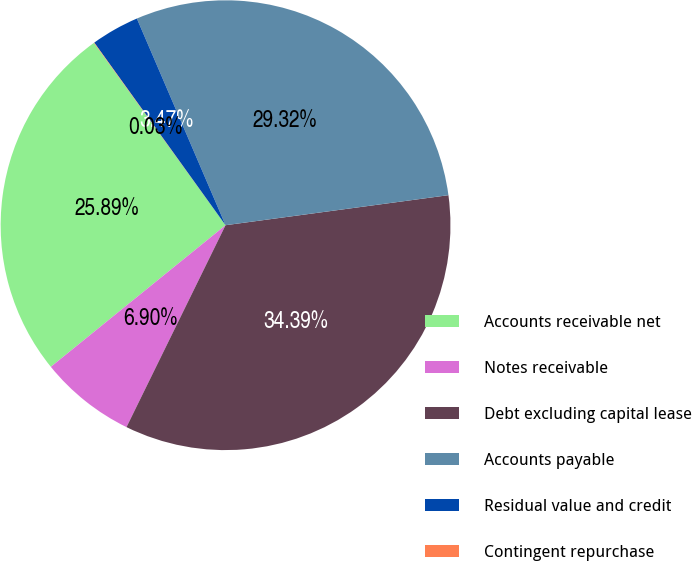<chart> <loc_0><loc_0><loc_500><loc_500><pie_chart><fcel>Accounts receivable net<fcel>Notes receivable<fcel>Debt excluding capital lease<fcel>Accounts payable<fcel>Residual value and credit<fcel>Contingent repurchase<nl><fcel>25.89%<fcel>6.9%<fcel>34.39%<fcel>29.32%<fcel>3.47%<fcel>0.03%<nl></chart> 